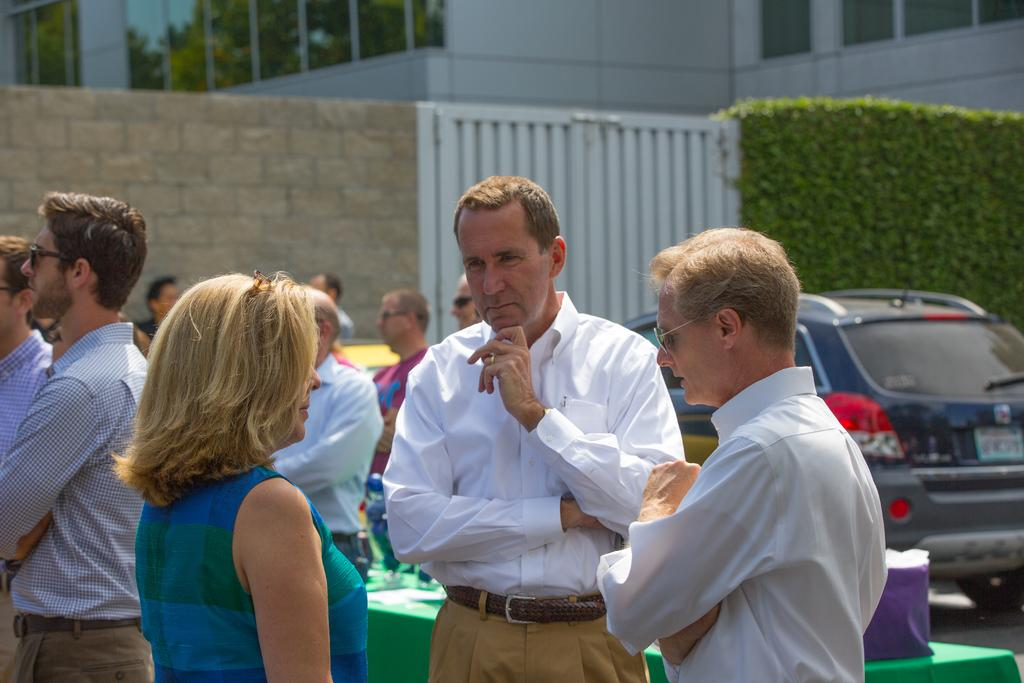How many people are in the image? There is a group of people in the image, but the exact number cannot be determined from the provided facts. What type of vehicle is in the image? There is a vehicle in the image, but the specific type cannot be determined from the provided facts. What is the cloth used for in the image? The purpose of the cloth in the image cannot be determined from the provided facts. What objects are present in the image? There are objects in the image, but their specific nature cannot be determined from the provided facts. What can be seen in the background of the image? In the background of the image, there is a wall, a wooden gate, plants, and a building. Where is the store located in the image? There is no store present in the image. What type of pot is being used by the people in the image? There is no pot present in the image. 